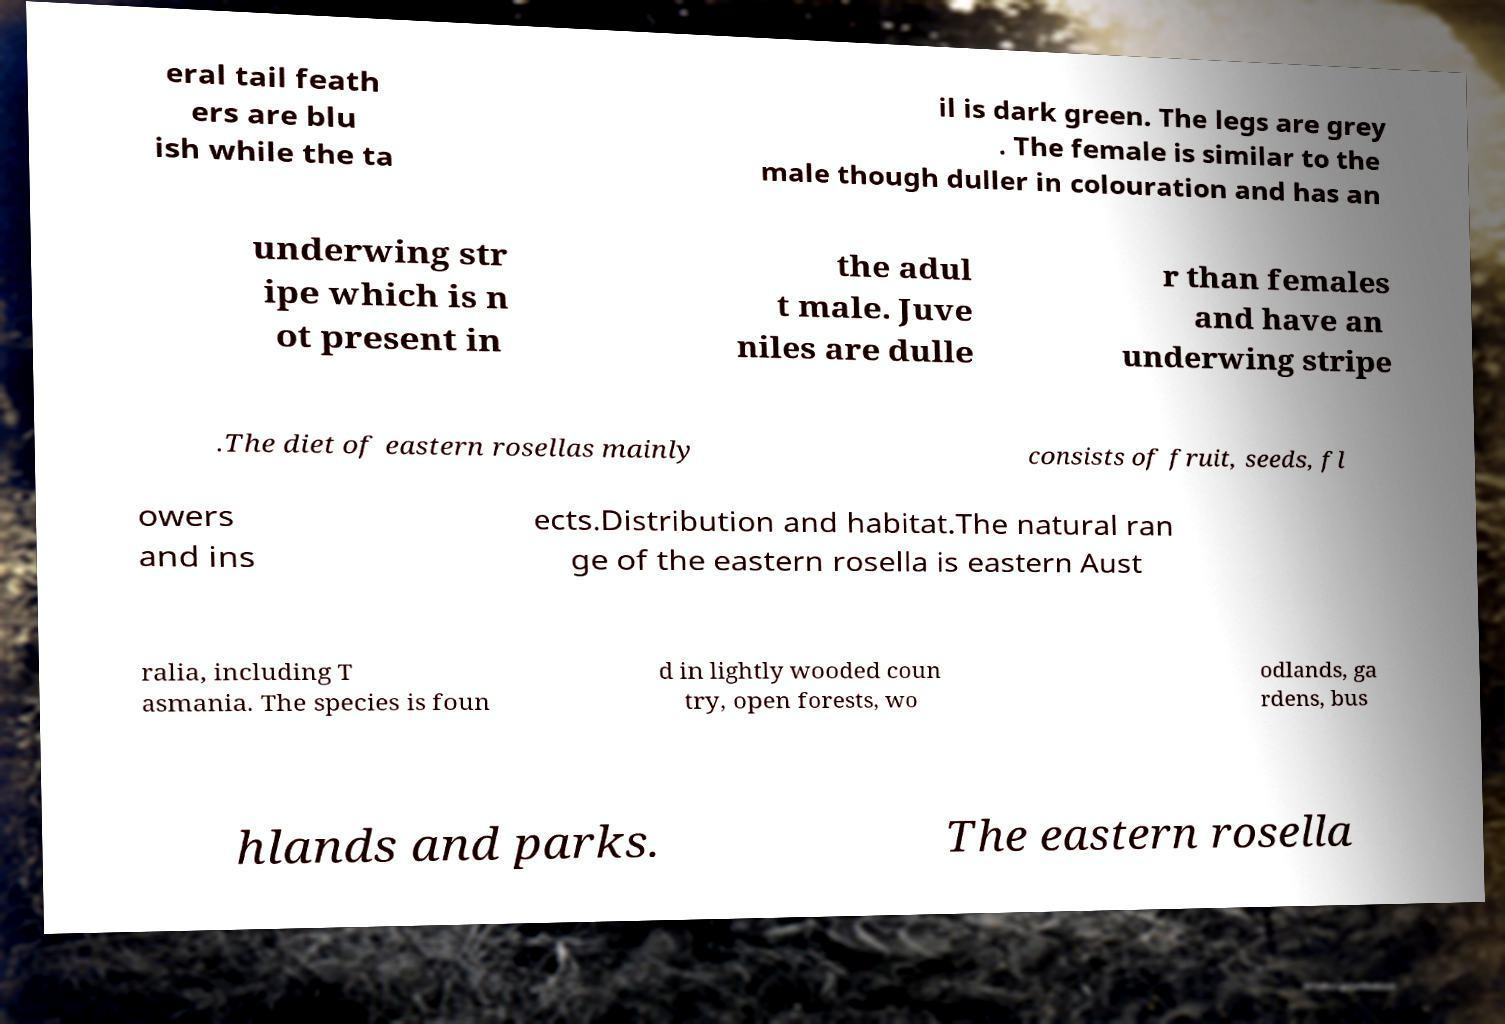Please identify and transcribe the text found in this image. eral tail feath ers are blu ish while the ta il is dark green. The legs are grey . The female is similar to the male though duller in colouration and has an underwing str ipe which is n ot present in the adul t male. Juve niles are dulle r than females and have an underwing stripe .The diet of eastern rosellas mainly consists of fruit, seeds, fl owers and ins ects.Distribution and habitat.The natural ran ge of the eastern rosella is eastern Aust ralia, including T asmania. The species is foun d in lightly wooded coun try, open forests, wo odlands, ga rdens, bus hlands and parks. The eastern rosella 